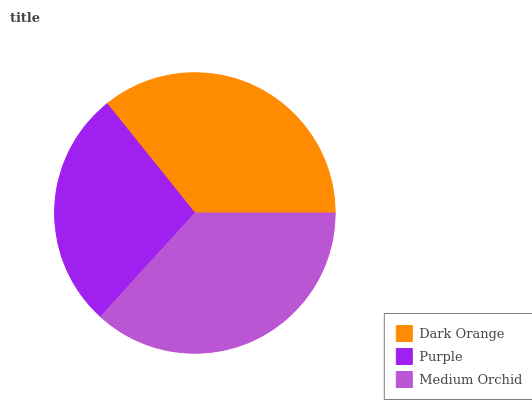Is Purple the minimum?
Answer yes or no. Yes. Is Medium Orchid the maximum?
Answer yes or no. Yes. Is Medium Orchid the minimum?
Answer yes or no. No. Is Purple the maximum?
Answer yes or no. No. Is Medium Orchid greater than Purple?
Answer yes or no. Yes. Is Purple less than Medium Orchid?
Answer yes or no. Yes. Is Purple greater than Medium Orchid?
Answer yes or no. No. Is Medium Orchid less than Purple?
Answer yes or no. No. Is Dark Orange the high median?
Answer yes or no. Yes. Is Dark Orange the low median?
Answer yes or no. Yes. Is Purple the high median?
Answer yes or no. No. Is Medium Orchid the low median?
Answer yes or no. No. 